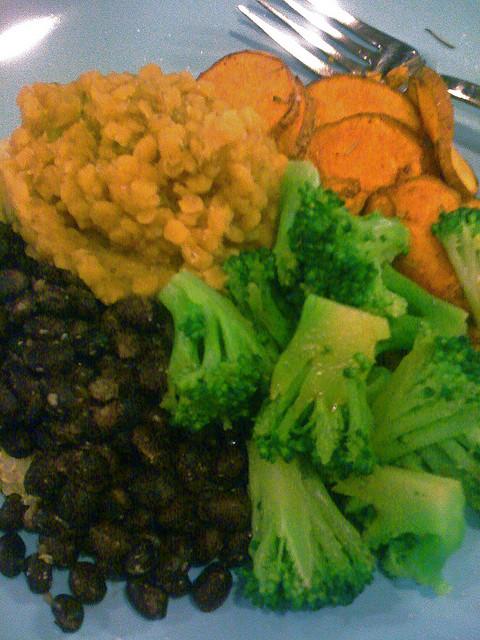Is there a fork?
Give a very brief answer. Yes. How many different ingredients can you see?
Write a very short answer. 4. What is the orange ingredient?
Keep it brief. Sweet potato. Is this a vegetarian meal?
Short answer required. Yes. What percentage of the food on the plate is vegetable?
Short answer required. 100. Is this dish healthy?
Quick response, please. Yes. Are noodles present?
Keep it brief. No. Is this food good?
Give a very brief answer. Yes. What is the brown stuff on the left?
Give a very brief answer. Beans. What color is the plate?
Quick response, please. White. What color is the plate the food is on?
Keep it brief. White. Does this meal contain any carbohydrate rich foods?
Keep it brief. Yes. Where is the broccoli?
Quick response, please. Bottom right. Is there corn on the plate?
Answer briefly. Yes. What is in this salad?
Keep it brief. Broccoli. 